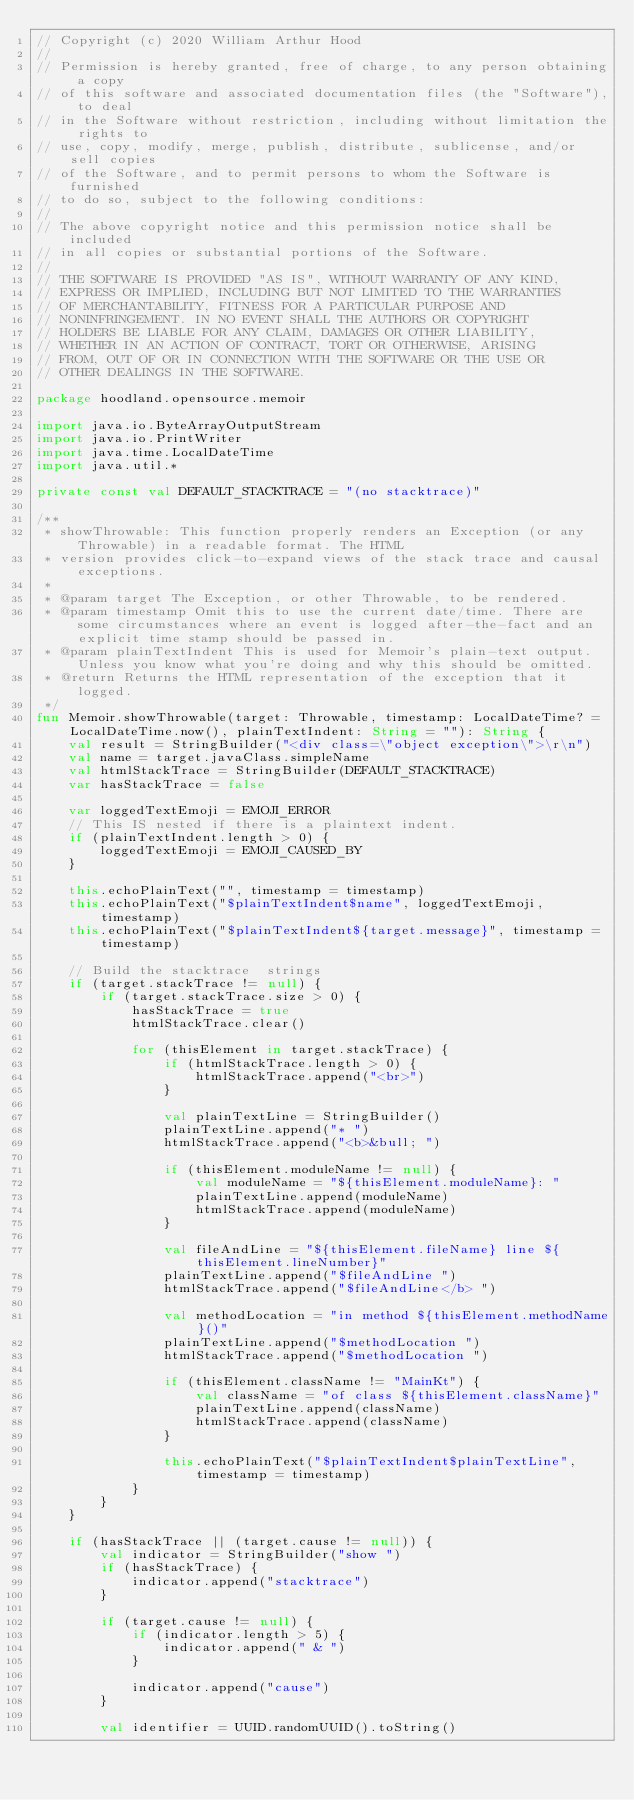<code> <loc_0><loc_0><loc_500><loc_500><_Kotlin_>// Copyright (c) 2020 William Arthur Hood
//
// Permission is hereby granted, free of charge, to any person obtaining a copy
// of this software and associated documentation files (the "Software"), to deal
// in the Software without restriction, including without limitation the rights to
// use, copy, modify, merge, publish, distribute, sublicense, and/or sell copies
// of the Software, and to permit persons to whom the Software is furnished
// to do so, subject to the following conditions:
//
// The above copyright notice and this permission notice shall be included
// in all copies or substantial portions of the Software.
//
// THE SOFTWARE IS PROVIDED "AS IS", WITHOUT WARRANTY OF ANY KIND,
// EXPRESS OR IMPLIED, INCLUDING BUT NOT LIMITED TO THE WARRANTIES
// OF MERCHANTABILITY, FITNESS FOR A PARTICULAR PURPOSE AND
// NONINFRINGEMENT. IN NO EVENT SHALL THE AUTHORS OR COPYRIGHT
// HOLDERS BE LIABLE FOR ANY CLAIM, DAMAGES OR OTHER LIABILITY,
// WHETHER IN AN ACTION OF CONTRACT, TORT OR OTHERWISE, ARISING
// FROM, OUT OF OR IN CONNECTION WITH THE SOFTWARE OR THE USE OR
// OTHER DEALINGS IN THE SOFTWARE.

package hoodland.opensource.memoir

import java.io.ByteArrayOutputStream
import java.io.PrintWriter
import java.time.LocalDateTime
import java.util.*

private const val DEFAULT_STACKTRACE = "(no stacktrace)"

/**
 * showThrowable: This function properly renders an Exception (or any Throwable) in a readable format. The HTML
 * version provides click-to-expand views of the stack trace and causal exceptions.
 *
 * @param target The Exception, or other Throwable, to be rendered.
 * @param timestamp Omit this to use the current date/time. There are some circumstances where an event is logged after-the-fact and an explicit time stamp should be passed in.
 * @param plainTextIndent This is used for Memoir's plain-text output. Unless you know what you're doing and why this should be omitted.
 * @return Returns the HTML representation of the exception that it logged.
 */
fun Memoir.showThrowable(target: Throwable, timestamp: LocalDateTime? = LocalDateTime.now(), plainTextIndent: String = ""): String {
    val result = StringBuilder("<div class=\"object exception\">\r\n")
    val name = target.javaClass.simpleName
    val htmlStackTrace = StringBuilder(DEFAULT_STACKTRACE)
    var hasStackTrace = false

    var loggedTextEmoji = EMOJI_ERROR
    // This IS nested if there is a plaintext indent.
    if (plainTextIndent.length > 0) {
        loggedTextEmoji = EMOJI_CAUSED_BY
    }

    this.echoPlainText("", timestamp = timestamp)
    this.echoPlainText("$plainTextIndent$name", loggedTextEmoji, timestamp)
    this.echoPlainText("$plainTextIndent${target.message}", timestamp = timestamp)

    // Build the stacktrace  strings
    if (target.stackTrace != null) {
        if (target.stackTrace.size > 0) {
            hasStackTrace = true
            htmlStackTrace.clear()

            for (thisElement in target.stackTrace) {
                if (htmlStackTrace.length > 0) {
                    htmlStackTrace.append("<br>")
                }

                val plainTextLine = StringBuilder()
                plainTextLine.append("* ")
                htmlStackTrace.append("<b>&bull; ")

                if (thisElement.moduleName != null) {
                    val moduleName = "${thisElement.moduleName}: "
                    plainTextLine.append(moduleName)
                    htmlStackTrace.append(moduleName)
                }

                val fileAndLine = "${thisElement.fileName} line ${thisElement.lineNumber}"
                plainTextLine.append("$fileAndLine ")
                htmlStackTrace.append("$fileAndLine</b> ")

                val methodLocation = "in method ${thisElement.methodName}()"
                plainTextLine.append("$methodLocation ")
                htmlStackTrace.append("$methodLocation ")

                if (thisElement.className != "MainKt") {
                    val className = "of class ${thisElement.className}"
                    plainTextLine.append(className)
                    htmlStackTrace.append(className)
                }

                this.echoPlainText("$plainTextIndent$plainTextLine", timestamp = timestamp)
            }
        }
    }

    if (hasStackTrace || (target.cause != null)) {
        val indicator = StringBuilder("show ")
        if (hasStackTrace) {
            indicator.append("stacktrace")
        }

        if (target.cause != null) {
            if (indicator.length > 5) {
                indicator.append(" & ")
            }

            indicator.append("cause")
        }

        val identifier = UUID.randomUUID().toString()</code> 